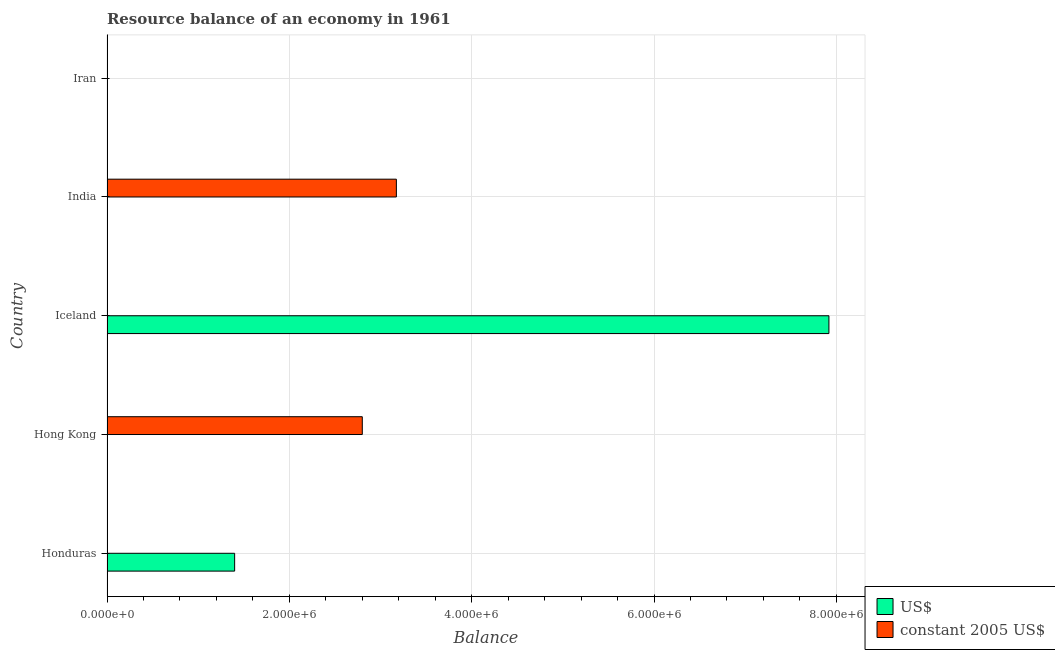How many bars are there on the 2nd tick from the top?
Give a very brief answer. 1. How many bars are there on the 1st tick from the bottom?
Make the answer very short. 1. What is the label of the 5th group of bars from the top?
Ensure brevity in your answer.  Honduras. Across all countries, what is the maximum resource balance in us$?
Offer a terse response. 7.92e+06. Across all countries, what is the minimum resource balance in constant us$?
Your response must be concise. 0. In which country was the resource balance in us$ maximum?
Your response must be concise. Iceland. What is the total resource balance in constant us$ in the graph?
Offer a terse response. 5.97e+06. What is the difference between the resource balance in us$ in Honduras and that in Iceland?
Make the answer very short. -6.52e+06. What is the difference between the resource balance in us$ in Honduras and the resource balance in constant us$ in Hong Kong?
Provide a short and direct response. -1.40e+06. What is the average resource balance in us$ per country?
Keep it short and to the point. 1.86e+06. What is the ratio of the resource balance in us$ in Honduras to that in Iceland?
Offer a very short reply. 0.18. What is the difference between the highest and the lowest resource balance in us$?
Make the answer very short. 7.92e+06. In how many countries, is the resource balance in constant us$ greater than the average resource balance in constant us$ taken over all countries?
Keep it short and to the point. 2. How many countries are there in the graph?
Your answer should be very brief. 5. What is the difference between two consecutive major ticks on the X-axis?
Give a very brief answer. 2.00e+06. How many legend labels are there?
Your answer should be compact. 2. What is the title of the graph?
Keep it short and to the point. Resource balance of an economy in 1961. What is the label or title of the X-axis?
Offer a terse response. Balance. What is the Balance in US$ in Honduras?
Ensure brevity in your answer.  1.40e+06. What is the Balance of constant 2005 US$ in Honduras?
Your answer should be compact. 0. What is the Balance in constant 2005 US$ in Hong Kong?
Keep it short and to the point. 2.80e+06. What is the Balance in US$ in Iceland?
Keep it short and to the point. 7.92e+06. What is the Balance in constant 2005 US$ in India?
Ensure brevity in your answer.  3.17e+06. What is the Balance of US$ in Iran?
Ensure brevity in your answer.  0. What is the Balance in constant 2005 US$ in Iran?
Give a very brief answer. 0. Across all countries, what is the maximum Balance in US$?
Your response must be concise. 7.92e+06. Across all countries, what is the maximum Balance in constant 2005 US$?
Offer a very short reply. 3.17e+06. Across all countries, what is the minimum Balance of US$?
Your answer should be very brief. 0. Across all countries, what is the minimum Balance in constant 2005 US$?
Make the answer very short. 0. What is the total Balance of US$ in the graph?
Ensure brevity in your answer.  9.32e+06. What is the total Balance of constant 2005 US$ in the graph?
Ensure brevity in your answer.  5.97e+06. What is the difference between the Balance in US$ in Honduras and that in Iceland?
Your response must be concise. -6.52e+06. What is the difference between the Balance in constant 2005 US$ in Hong Kong and that in India?
Ensure brevity in your answer.  -3.74e+05. What is the difference between the Balance of US$ in Honduras and the Balance of constant 2005 US$ in Hong Kong?
Provide a short and direct response. -1.40e+06. What is the difference between the Balance of US$ in Honduras and the Balance of constant 2005 US$ in India?
Provide a succinct answer. -1.77e+06. What is the difference between the Balance in US$ in Iceland and the Balance in constant 2005 US$ in India?
Provide a short and direct response. 4.74e+06. What is the average Balance in US$ per country?
Your answer should be very brief. 1.86e+06. What is the average Balance in constant 2005 US$ per country?
Offer a terse response. 1.19e+06. What is the ratio of the Balance in US$ in Honduras to that in Iceland?
Offer a terse response. 0.18. What is the ratio of the Balance in constant 2005 US$ in Hong Kong to that in India?
Your answer should be compact. 0.88. What is the difference between the highest and the lowest Balance of US$?
Offer a terse response. 7.92e+06. What is the difference between the highest and the lowest Balance in constant 2005 US$?
Offer a very short reply. 3.17e+06. 